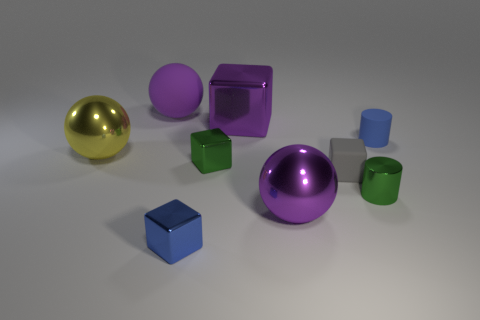Subtract 1 blocks. How many blocks are left? 3 Add 1 tiny purple metal things. How many objects exist? 10 Subtract all spheres. How many objects are left? 6 Add 8 large purple rubber objects. How many large purple rubber objects are left? 9 Add 8 tiny brown matte objects. How many tiny brown matte objects exist? 8 Subtract 0 yellow cylinders. How many objects are left? 9 Subtract all big cyan matte cubes. Subtract all gray matte cubes. How many objects are left? 8 